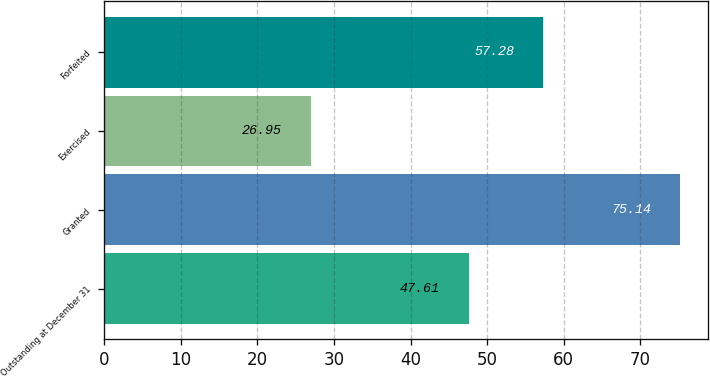Convert chart. <chart><loc_0><loc_0><loc_500><loc_500><bar_chart><fcel>Outstanding at December 31<fcel>Granted<fcel>Exercised<fcel>Forfeited<nl><fcel>47.61<fcel>75.14<fcel>26.95<fcel>57.28<nl></chart> 